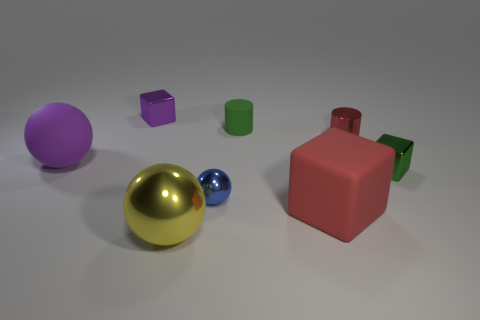Do the matte block and the shiny cylinder have the same color?
Make the answer very short. Yes. What material is the large object that is the same color as the tiny shiny cylinder?
Give a very brief answer. Rubber. Is there anything else of the same color as the rubber sphere?
Give a very brief answer. Yes. What shape is the object that is the same color as the rubber cylinder?
Provide a succinct answer. Cube. Are there any big things that have the same color as the rubber ball?
Offer a very short reply. No. There is a red matte cube; is its size the same as the yellow ball that is left of the tiny red shiny object?
Make the answer very short. Yes. There is a big purple matte sphere on the left side of the large matte object right of the green cylinder; how many tiny metal cubes are behind it?
Your response must be concise. 1. How many yellow metallic things are to the right of the rubber cylinder?
Offer a terse response. 0. There is a tiny block behind the small block that is right of the small purple block; what color is it?
Provide a short and direct response. Purple. How many other things are there of the same material as the red block?
Give a very brief answer. 2. 